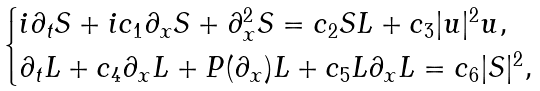<formula> <loc_0><loc_0><loc_500><loc_500>\begin{cases} i \partial _ { t } S + i c _ { 1 } \partial _ { x } S + \partial ^ { 2 } _ { x } S = c _ { 2 } S L + c _ { 3 } | u | ^ { 2 } u , \\ \partial _ { t } L + c _ { 4 } \partial _ { x } L + P ( \partial _ { x } ) L + c _ { 5 } L \partial _ { x } L = c _ { 6 } | S | ^ { 2 } , \end{cases}</formula> 